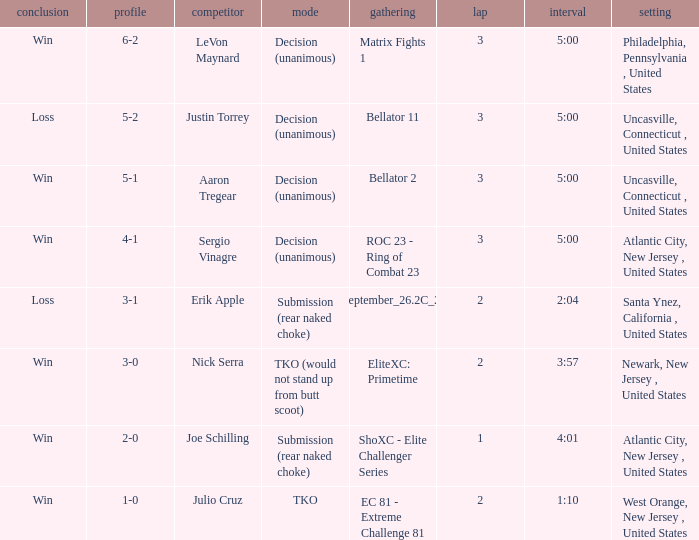What was the round that Sergio Vinagre had a time of 5:00? 3.0. 